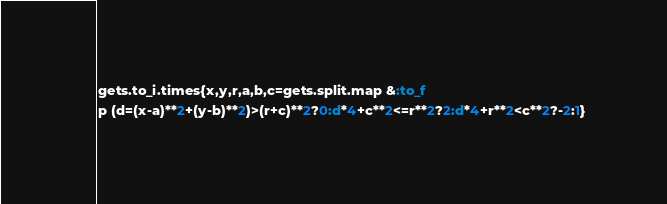<code> <loc_0><loc_0><loc_500><loc_500><_Ruby_>gets.to_i.times{x,y,r,a,b,c=gets.split.map &:to_f
p (d=(x-a)**2+(y-b)**2)>(r+c)**2?0:d*4+c**2<=r**2?2:d*4+r**2<c**2?-2:1}</code> 